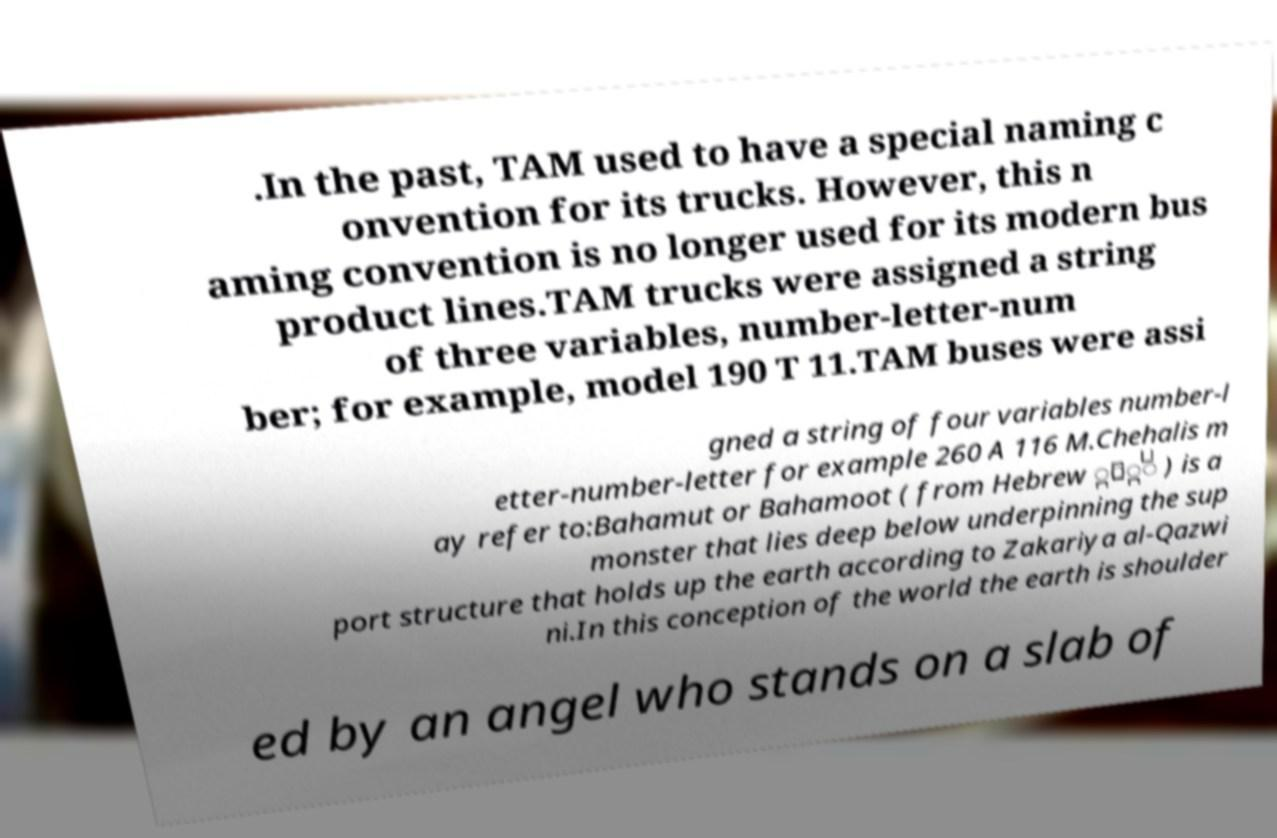There's text embedded in this image that I need extracted. Can you transcribe it verbatim? .In the past, TAM used to have a special naming c onvention for its trucks. However, this n aming convention is no longer used for its modern bus product lines.TAM trucks were assigned a string of three variables, number-letter-num ber; for example, model 190 T 11.TAM buses were assi gned a string of four variables number-l etter-number-letter for example 260 A 116 M.Chehalis m ay refer to:Bahamut or Bahamoot ( from Hebrew ְֵֹּ ) is a monster that lies deep below underpinning the sup port structure that holds up the earth according to Zakariya al-Qazwi ni.In this conception of the world the earth is shoulder ed by an angel who stands on a slab of 